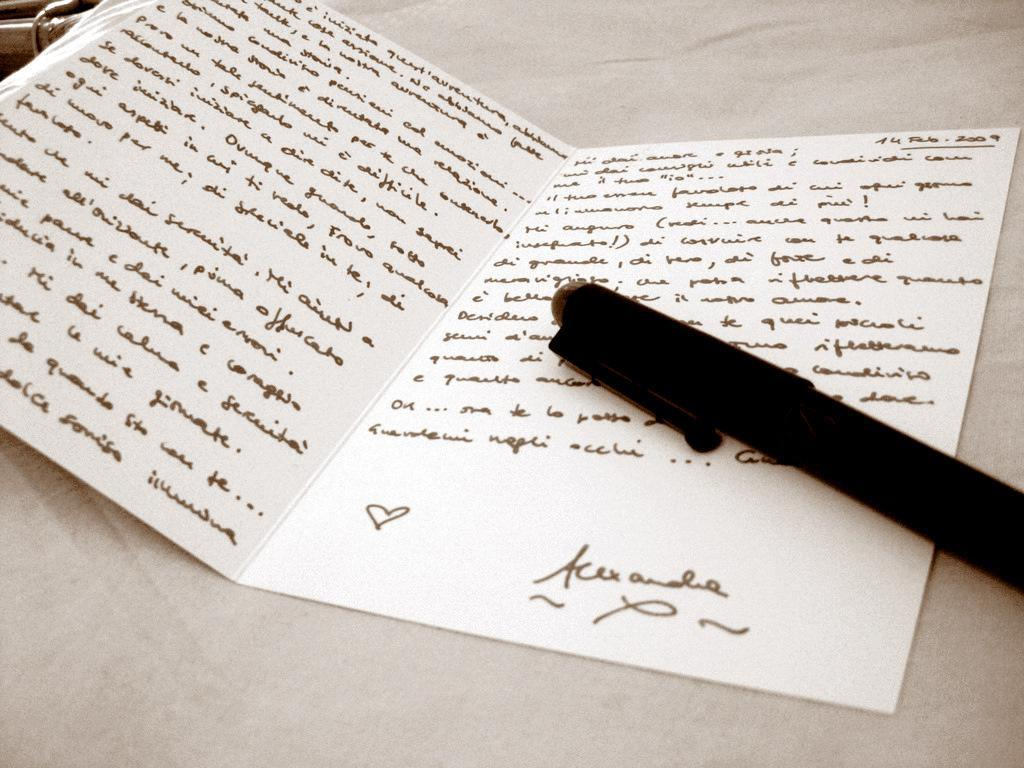What object is the main subject of the image? There is a greeting card in the image. What can be seen on the greeting card? There is writing on the greeting card. What tool was used to create the writing on the greeting card? The writing on the greeting card was done using a pen. What type of plate is visible in the image? There is no plate present in the image. What country is the visitor from in the image? There is no visitor present in the image, and therefore no information about their country of origin. 